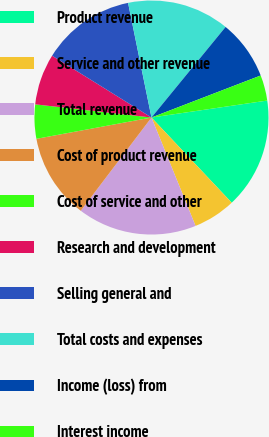Convert chart to OTSL. <chart><loc_0><loc_0><loc_500><loc_500><pie_chart><fcel>Product revenue<fcel>Service and other revenue<fcel>Total revenue<fcel>Cost of product revenue<fcel>Cost of service and other<fcel>Research and development<fcel>Selling general and<fcel>Total costs and expenses<fcel>Income (loss) from<fcel>Interest income<nl><fcel>15.29%<fcel>5.88%<fcel>16.47%<fcel>11.76%<fcel>4.71%<fcel>7.06%<fcel>12.94%<fcel>14.12%<fcel>8.24%<fcel>3.53%<nl></chart> 